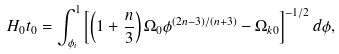<formula> <loc_0><loc_0><loc_500><loc_500>H _ { 0 } t _ { 0 } = \int _ { \phi _ { i } } ^ { 1 } \left [ \left ( 1 + \frac { n } { 3 } \right ) \Omega _ { 0 } \phi ^ { ( 2 n - 3 ) / ( n + 3 ) } - \Omega _ { k 0 } \right ] ^ { - 1 / 2 } d \phi ,</formula> 